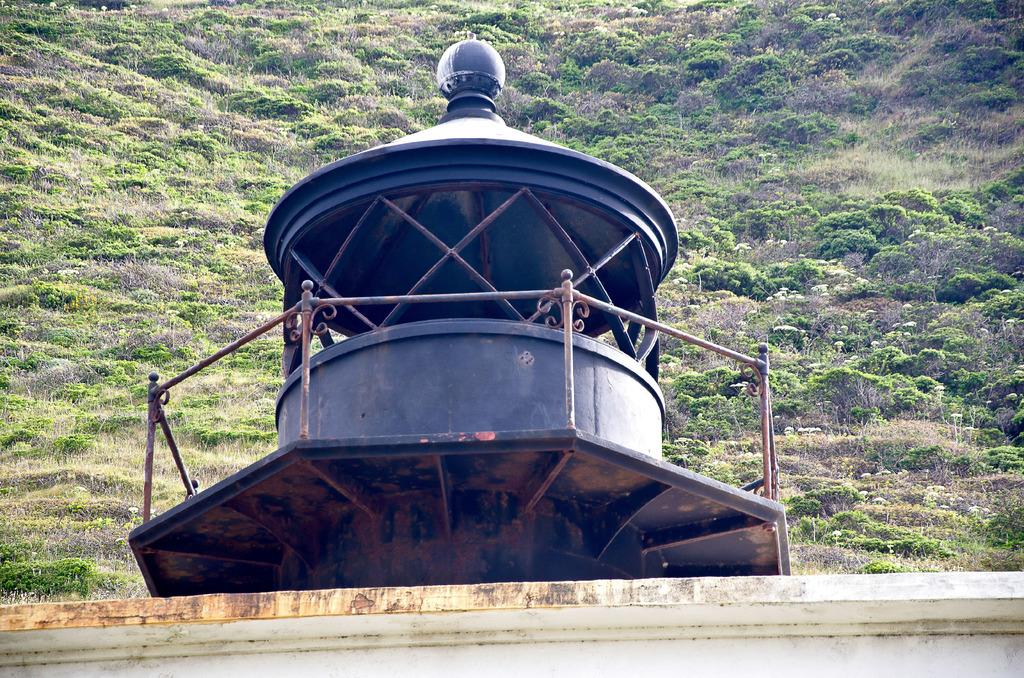What type of structure is present in the image? There is a shelter in the image. What can be seen near the shelter? There is a rod railing in the image. What else is present in the image? There is a wall in the image. What can be seen in the background of the image? There are plants visible in the background of the image. What type of bells can be heard ringing in the image? There are no bells present in the image, and therefore no sound can be heard. What mode of transport is visible in the image? There is no mode of transport visible in the image. 